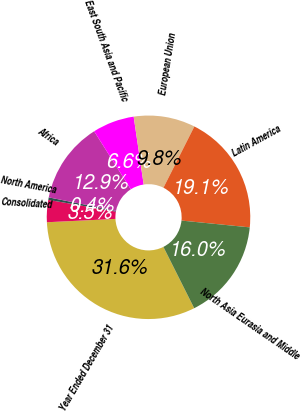Convert chart. <chart><loc_0><loc_0><loc_500><loc_500><pie_chart><fcel>Year Ended December 31<fcel>Consolidated<fcel>North America<fcel>Africa<fcel>East South Asia and Pacific<fcel>European Union<fcel>Latin America<fcel>North Asia Eurasia and Middle<nl><fcel>31.63%<fcel>3.52%<fcel>0.39%<fcel>12.89%<fcel>6.64%<fcel>9.77%<fcel>19.14%<fcel>16.01%<nl></chart> 